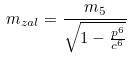Convert formula to latex. <formula><loc_0><loc_0><loc_500><loc_500>m _ { z a l } = \frac { m _ { 5 } } { \sqrt { 1 - \frac { p ^ { 6 } } { c ^ { 6 } } } }</formula> 